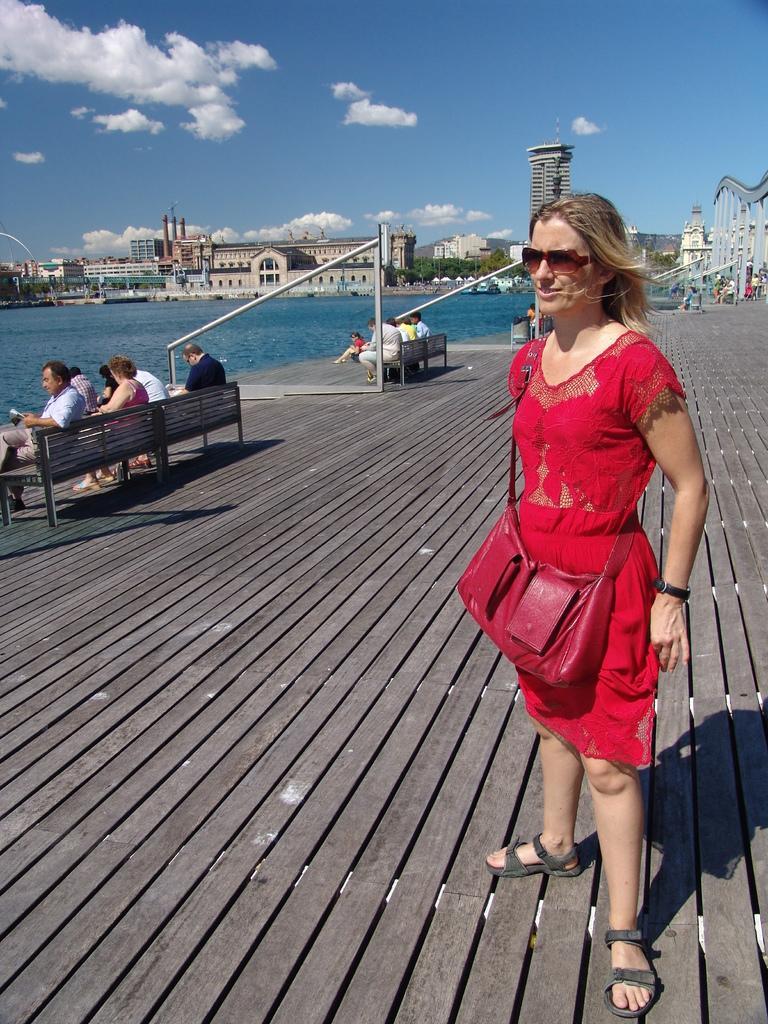How would you summarize this image in a sentence or two? In the picture i can see a woman wearing red color dress standing and also carrying bag, on left side of the picture there are some persons sitting on benches, there is water and in the background of the picture there are some buildings and clear sky. 